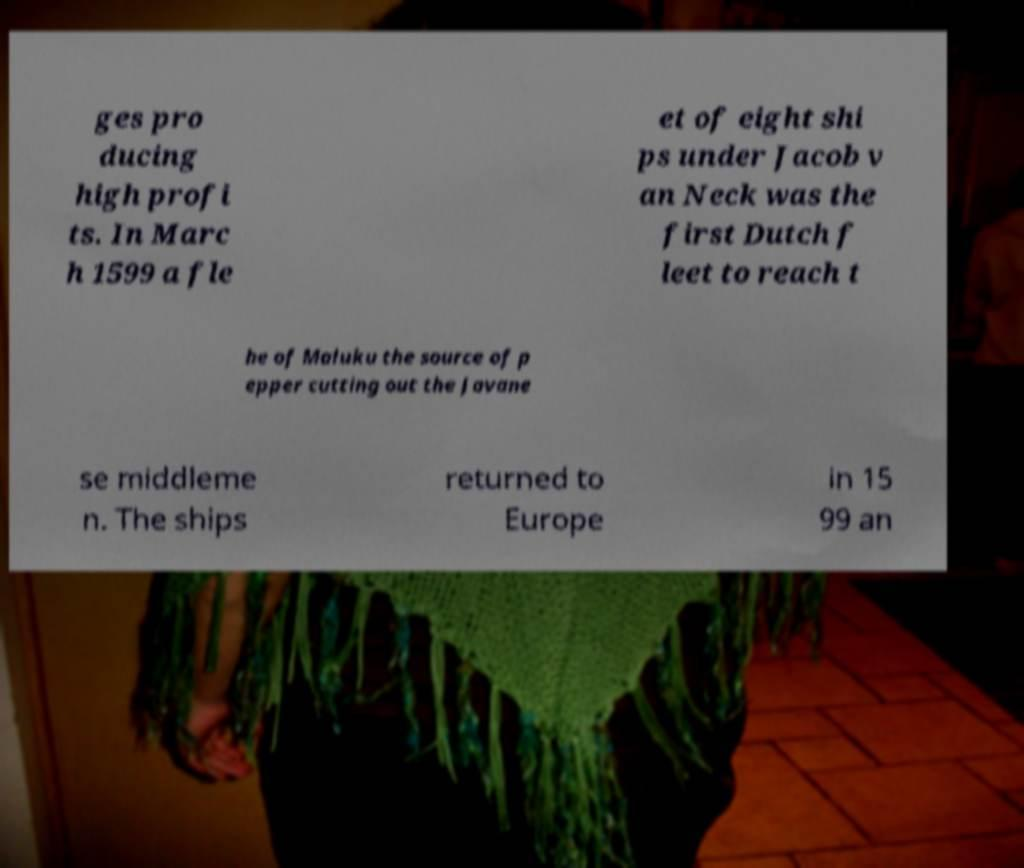Please identify and transcribe the text found in this image. ges pro ducing high profi ts. In Marc h 1599 a fle et of eight shi ps under Jacob v an Neck was the first Dutch f leet to reach t he of Maluku the source of p epper cutting out the Javane se middleme n. The ships returned to Europe in 15 99 an 